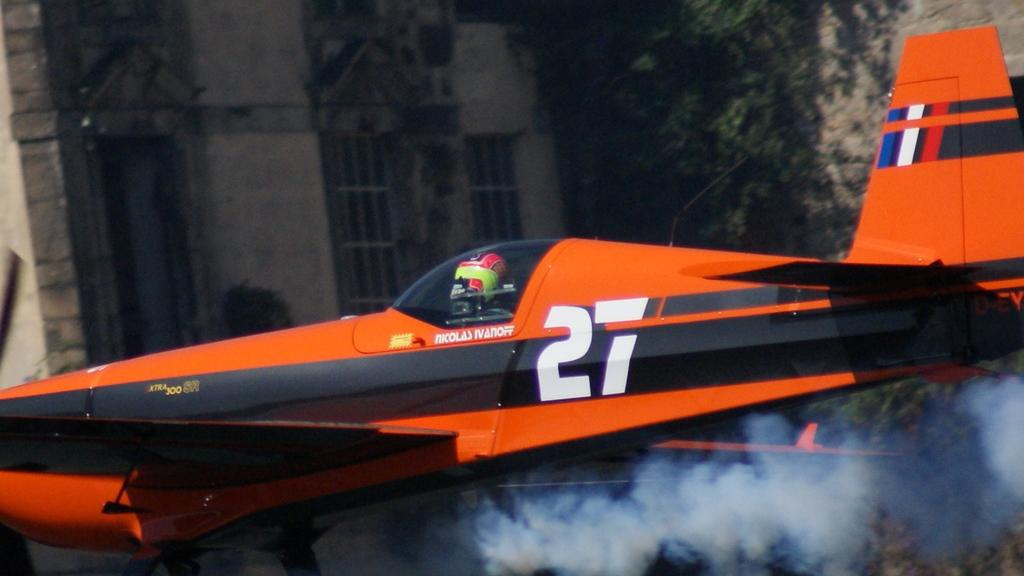<image>
Create a compact narrative representing the image presented. Nicolas Ivanoff written in red on a red and black helicopter. 